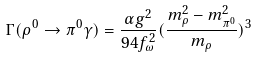<formula> <loc_0><loc_0><loc_500><loc_500>\Gamma ( \rho ^ { 0 } \rightarrow \pi ^ { 0 } \gamma ) = \frac { \alpha g ^ { 2 } } { 9 4 f _ { \omega } ^ { 2 } } ( \frac { m _ { \rho } ^ { 2 } - m _ { \pi ^ { 0 } } ^ { 2 } } { m _ { \rho } } ) ^ { 3 }</formula> 